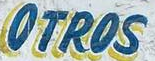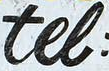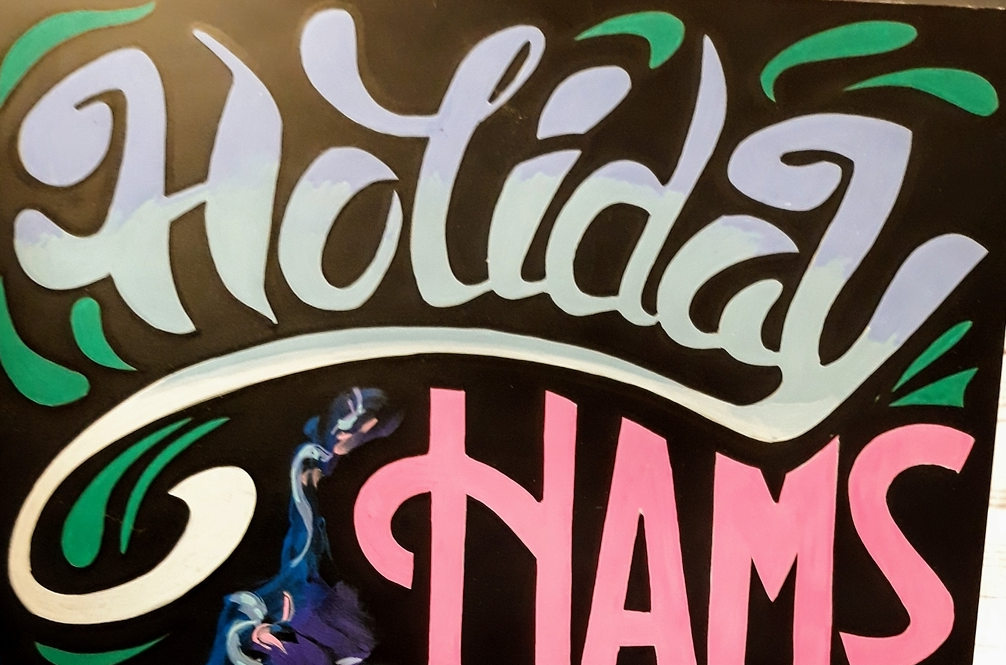Transcribe the words shown in these images in order, separated by a semicolon. OTROS; tel; Holiday 